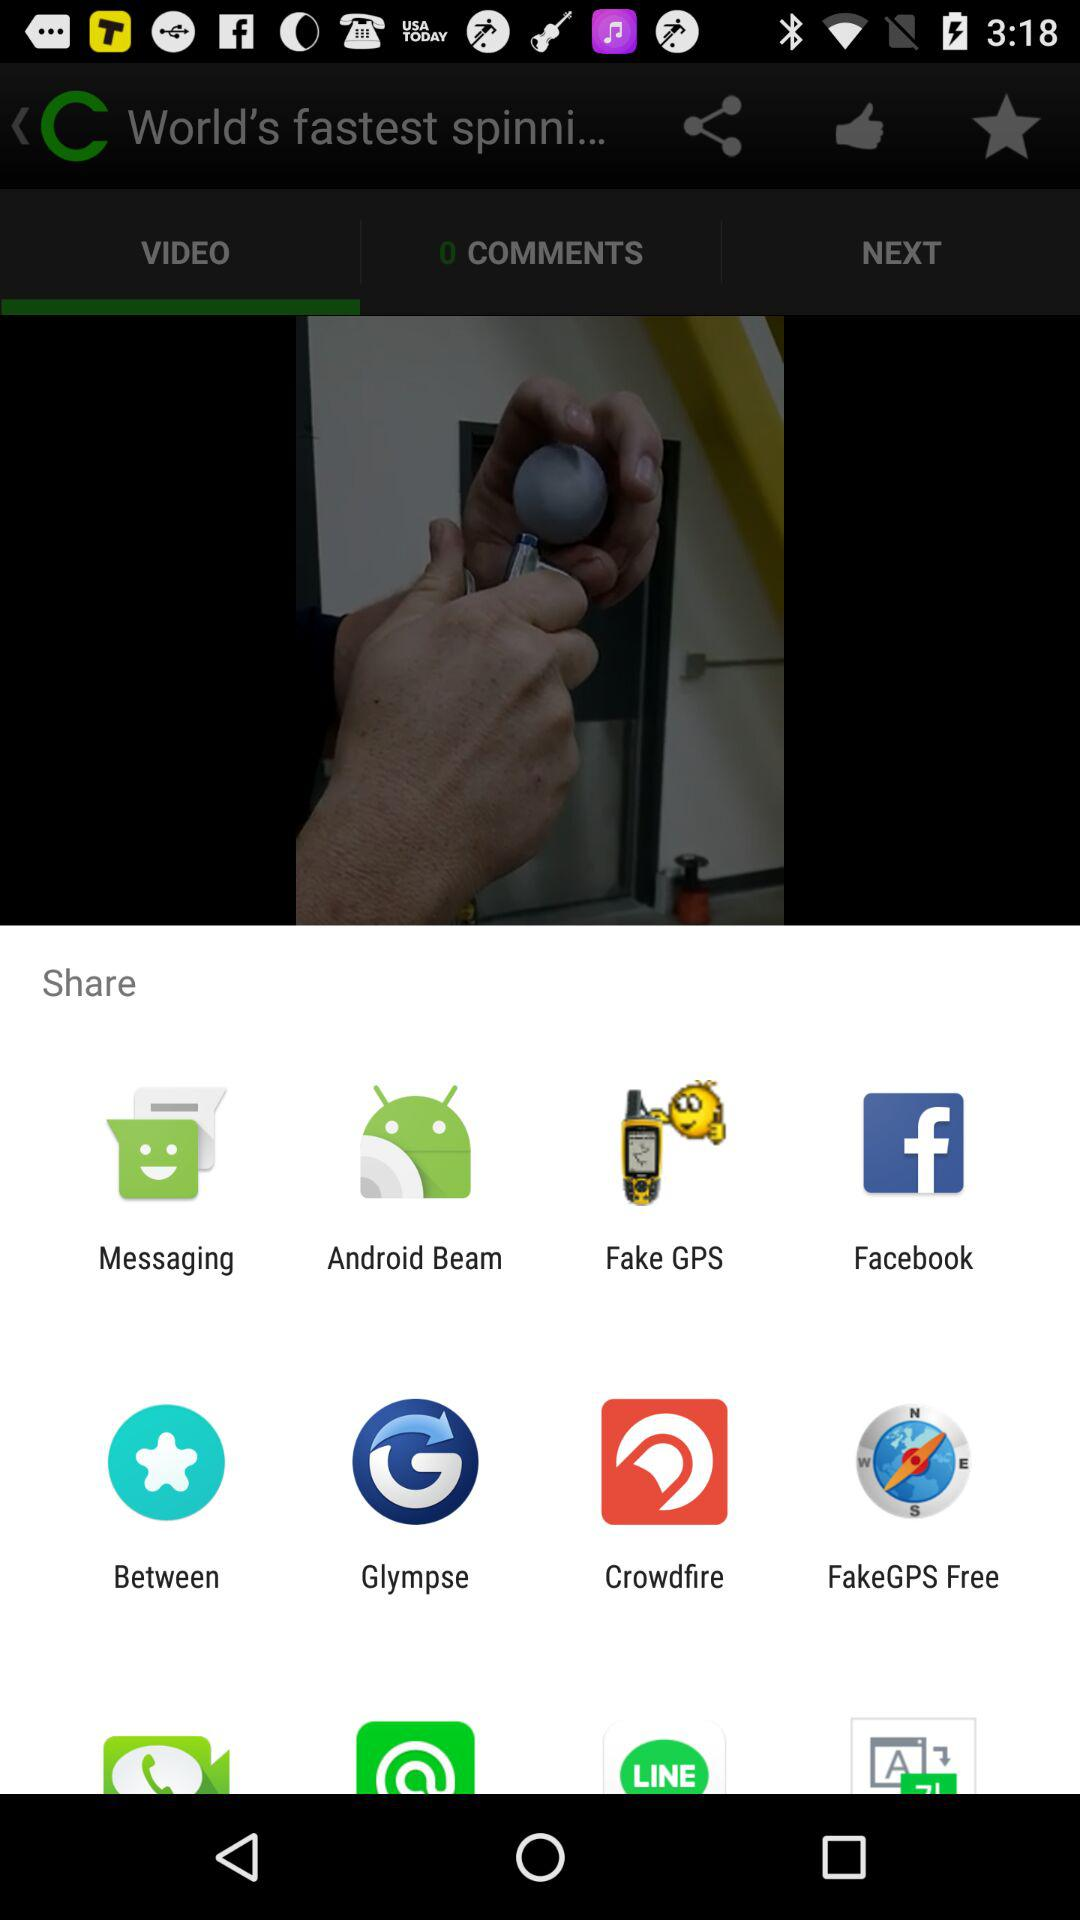Which applications can be used to share? The applications "Messaging", "Android Beam", "Fake GPS", "Facebook", "Between", "Glympse", "Crowdfire" and "FakeGPS Free" can be used to share. 